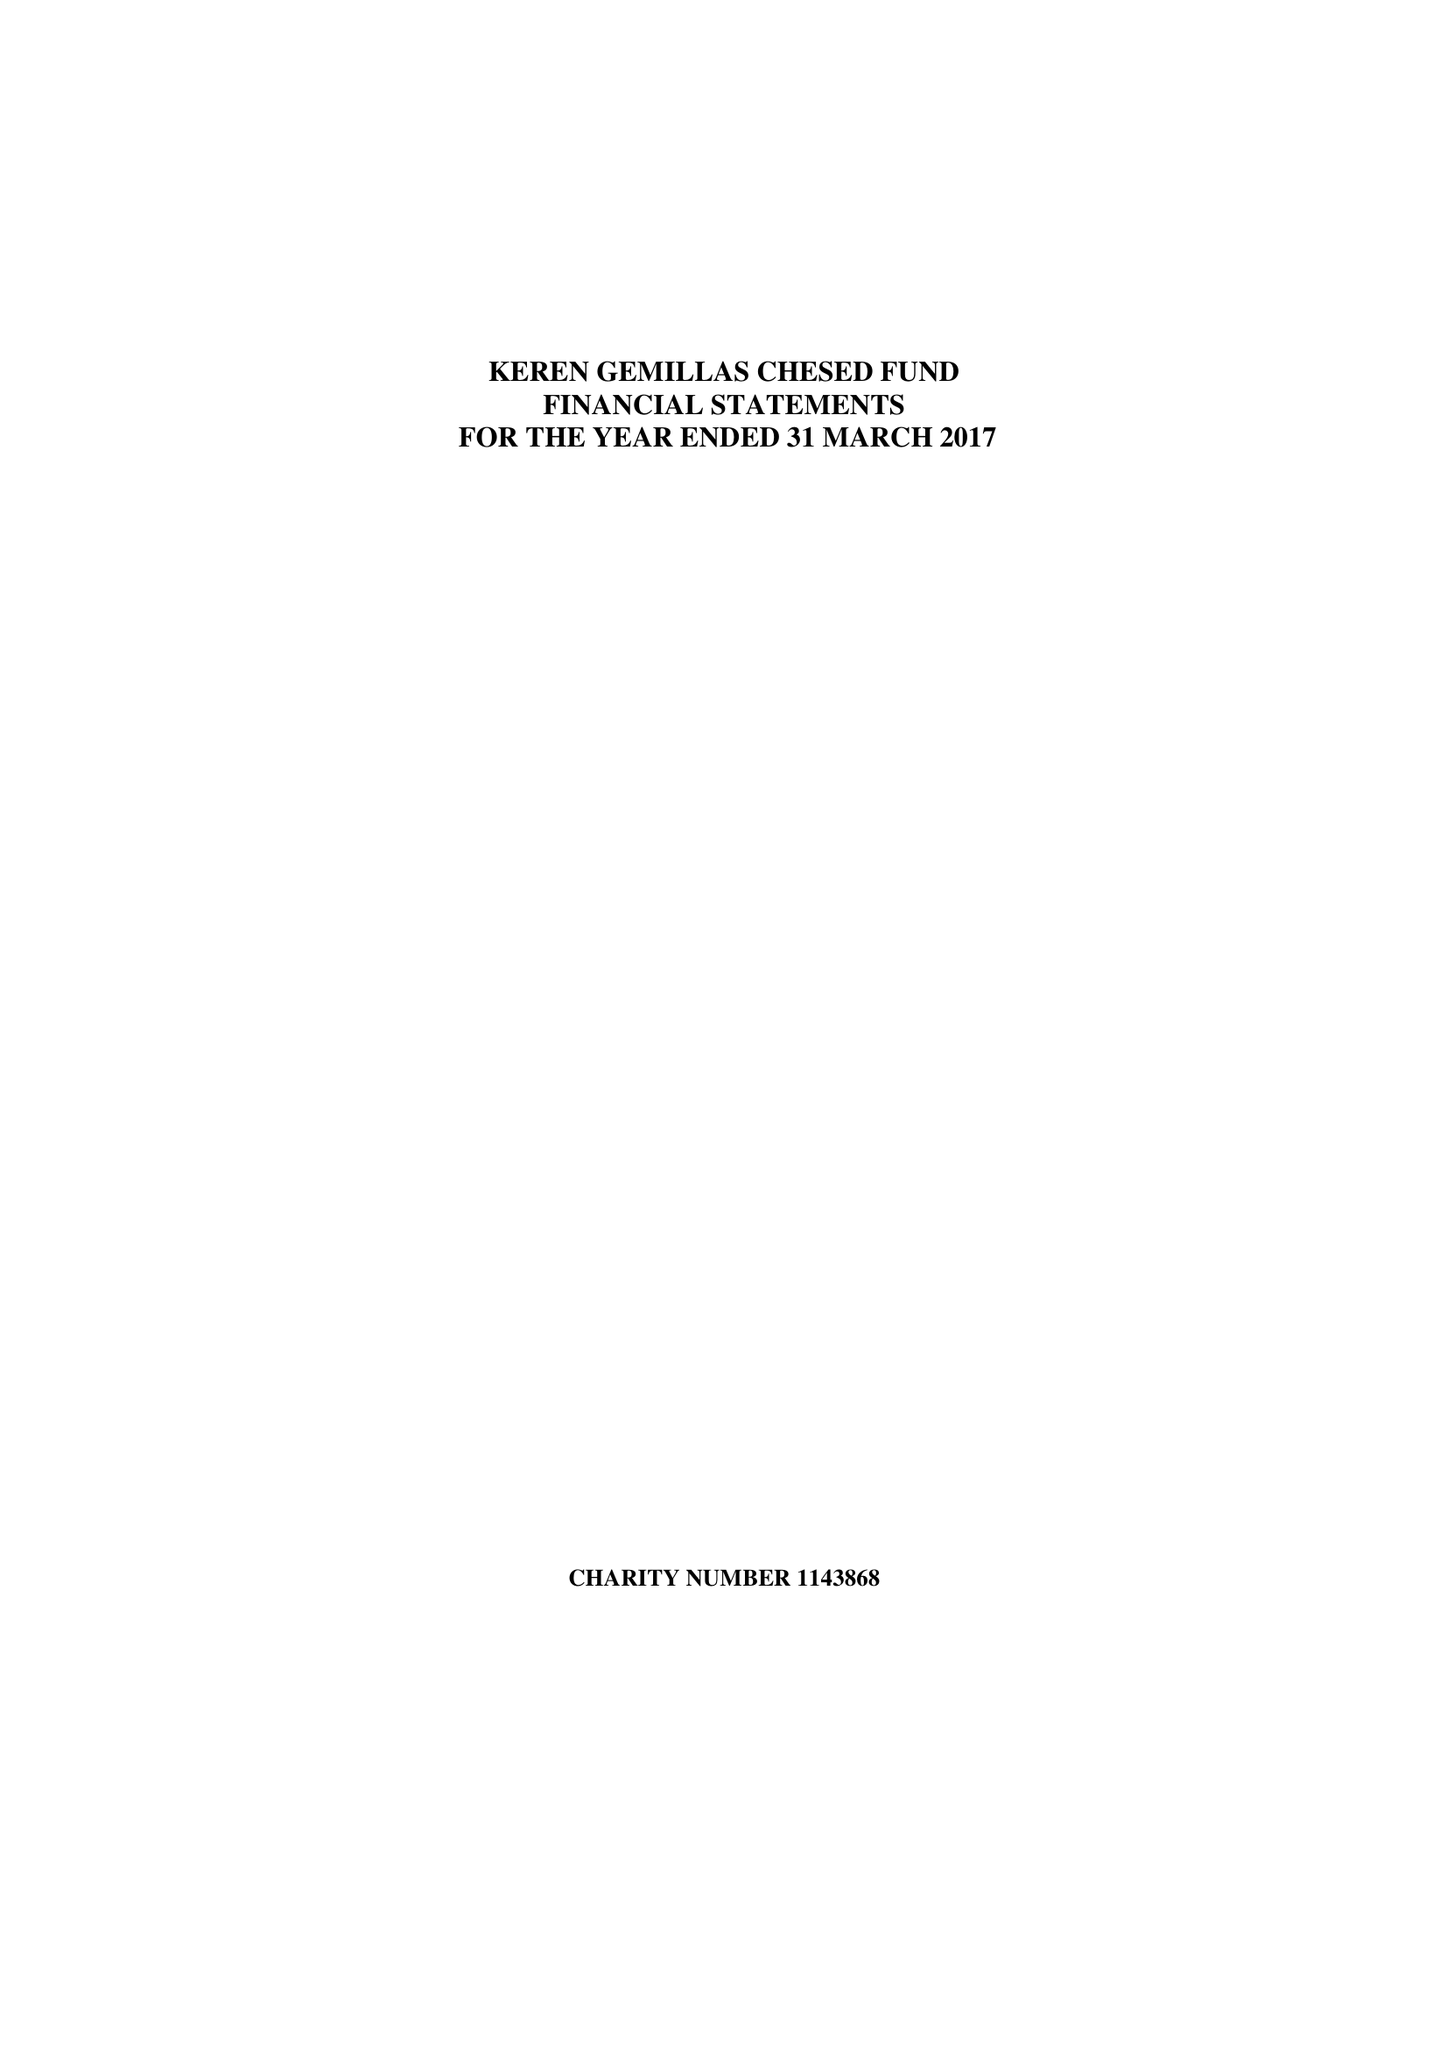What is the value for the address__post_town?
Answer the question using a single word or phrase. None 